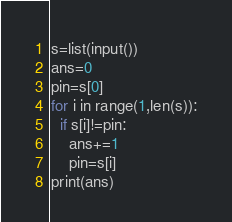<code> <loc_0><loc_0><loc_500><loc_500><_Python_>s=list(input())
ans=0
pin=s[0]
for i in range(1,len(s)):
  if s[i]!=pin:
    ans+=1
    pin=s[i]
print(ans)
</code> 